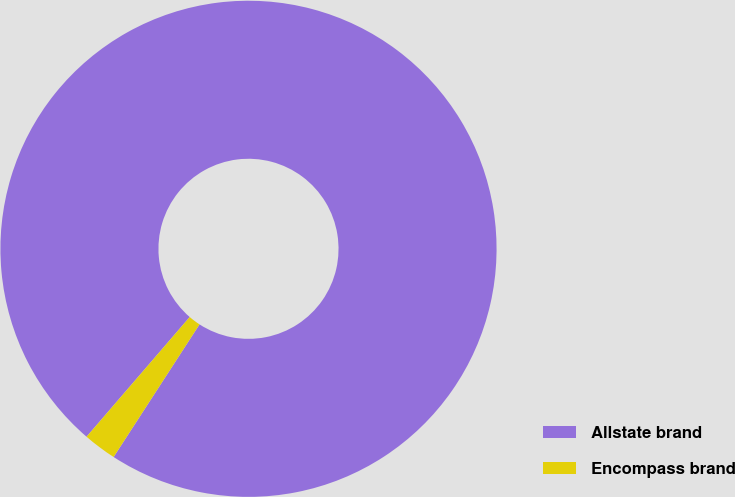Convert chart. <chart><loc_0><loc_0><loc_500><loc_500><pie_chart><fcel>Allstate brand<fcel>Encompass brand<nl><fcel>97.83%<fcel>2.17%<nl></chart> 